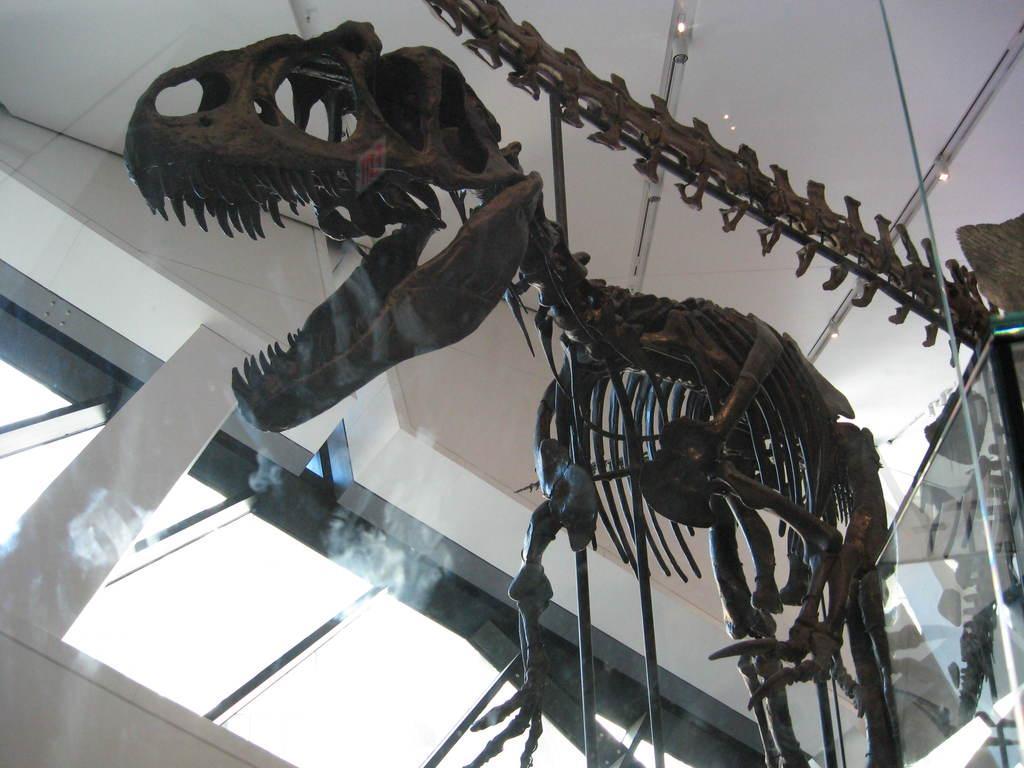Could you give a brief overview of what you see in this image? In the image we can see there is a bone statue of a dinosaur kept in the building. 